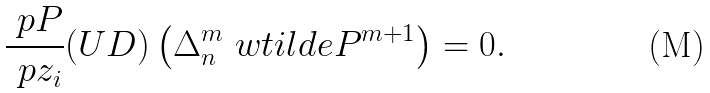<formula> <loc_0><loc_0><loc_500><loc_500>\frac { \ p P } { \ p z _ { i } } ( U D ) \left ( \Delta _ { n } ^ { m } \ w t i l d e P ^ { m + 1 } \right ) = 0 .</formula> 